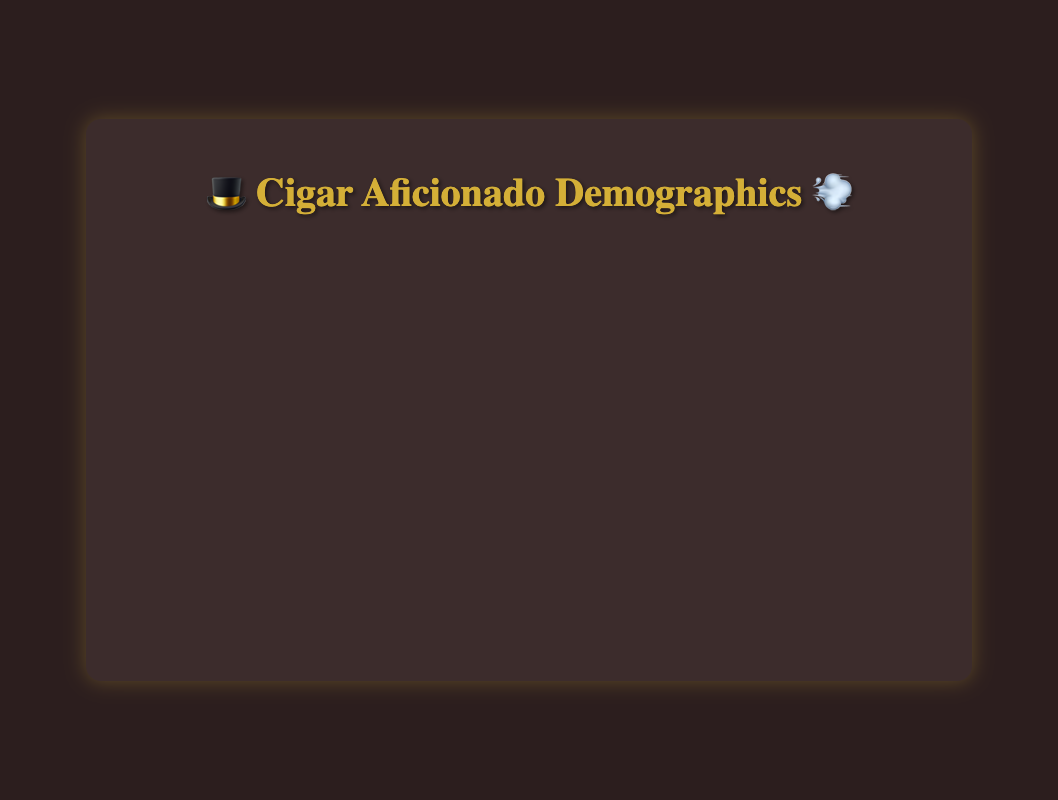What's the range of age groups shown in the chart? The x-axis represents age groups, which are listed from "25-34 👨‍💼" to "65+ 👨‍💼". The five age groups are "25-34 👨‍💼", "35-44 👨‍💼", "45-54 👨‍💼", "55-64 👨‍💼", and "65+ 👨‍💼".
Answer: "25-34 👨‍💼" to "65+ 👨‍💼" How does income level distribution change across age groups? For each age group, the percentage of cigar aficionados increases with higher income levels. For instance, in the "25-34 👨‍💼" group, the percentage increases from 5% at "$75k-$100k 💰" to 15% at "$250k+ 💰💰💰💰💰". The same trend is visible in other age groups.
Answer: Increases with income Which age group shows the highest percentage of cigar aficionados in the "$100k-$150k 💰💰" income level? In the "$100k-$150k 💰💰" income level, the "65+ 👨‍💼" age group has the highest percentage of cigar aficionados at 20%.
Answer: "65+ 👨‍💼" Compare the percentage of cigar aficionados in the "45-54 👨‍💼" age group for the "$75k-$100k 💰" and "$100k-$150k 💰💰" income levels. The percentage for "45-54 👨‍💼" age group at "$75k-$100k 💰" is 12%, and for "$100k-$150k 💰💰" it is 15%. The difference is (15% - 12%) = 3%.
Answer: 3% For which income level is the difference between the highest and lowest percentage in age groups the greatest? For the "$250k+ 💰💰💰💰💰" income level, the percentages range from 15% ("25-34 👨‍💼") to 35% ("55-64 👨‍💼"), giving the largest difference of (35% - 15%) = 20%.
Answer: "$250k+ 💰💰💰💰💰" What is the overall trend in the percentage of cigar aficionados for the "55-64 👨‍💼" age group across income levels? For the "55-64 👨‍💼" age group, the percentage of cigar aficionados increases consistently as income levels rise, from 12% in "$75k-$100k 💰" to 28% in "$250k+ 💰💰💰💰💰".
Answer: Increases consistently Which age group has a peak percentage within the "$150k-$200k 💰💰💰" income level, and what is that percentage? In the "$150k-$200k 💰💰💰" income level, the "55-64 👨‍💼" age group has the peak percentage of 25%.
Answer: "55-64 👨‍💼", 25% Is there any age group for which the percentage of cigar aficionados decreases with increasing income? For each age group depicted, the percentage of cigar aficionados does not decrease but increases with higher income levels.
Answer: No How do the age groups "35-44 👨‍💼" and "45-54 👨‍💼" compare in terms of percentage within the "$200k-$250k 💰💰💰💰" income level? In the "$200k-$250k 💰💰💰💰" income level, the percentage for "35-44 👨‍💼" is 18%, and for "45-54 👨‍💼" it is 22%. The "45-54 👨‍💼" age group has a 4% higher percentage than the "35-44 👨‍💼" age group.
Answer: "45-54 👨‍💼" is 4% higher What's the average percentage of cigar aficionados across all age groups for the "$150k-$200k 💰💰💰" income level? For the "$150k-$200k 💰💰💰" income level, the percentages are 10%, 15%, 20%, 25%, and 30% for each age group. Average percentage is (10% + 15% + 20% + 25% + 30%) / 5 = 20%.
Answer: 20% 